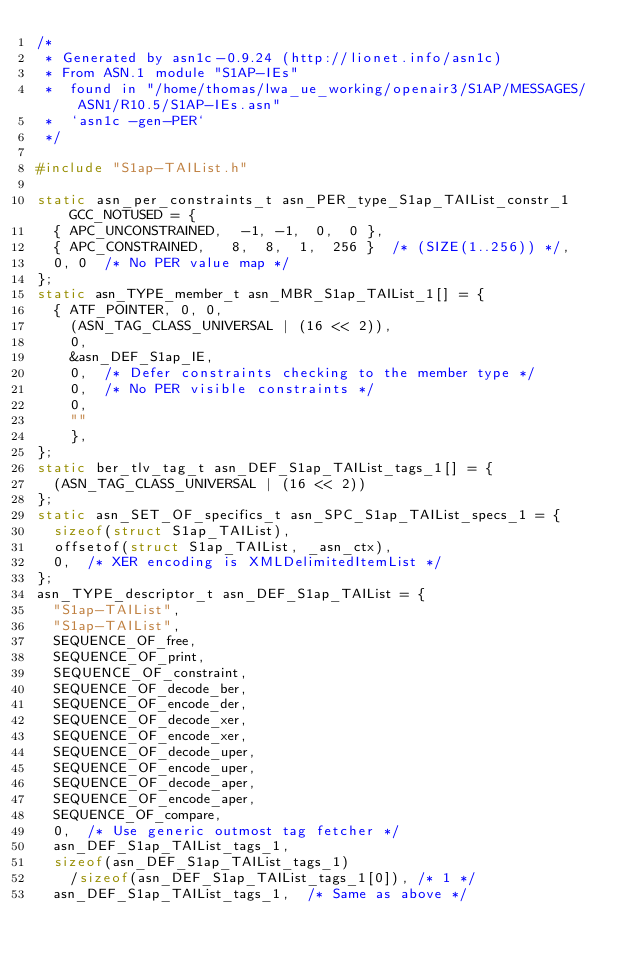Convert code to text. <code><loc_0><loc_0><loc_500><loc_500><_C_>/*
 * Generated by asn1c-0.9.24 (http://lionet.info/asn1c)
 * From ASN.1 module "S1AP-IEs"
 * 	found in "/home/thomas/lwa_ue_working/openair3/S1AP/MESSAGES/ASN1/R10.5/S1AP-IEs.asn"
 * 	`asn1c -gen-PER`
 */

#include "S1ap-TAIList.h"

static asn_per_constraints_t asn_PER_type_S1ap_TAIList_constr_1 GCC_NOTUSED = {
	{ APC_UNCONSTRAINED,	-1, -1,  0,  0 },
	{ APC_CONSTRAINED,	 8,  8,  1,  256 }	/* (SIZE(1..256)) */,
	0, 0	/* No PER value map */
};
static asn_TYPE_member_t asn_MBR_S1ap_TAIList_1[] = {
	{ ATF_POINTER, 0, 0,
		(ASN_TAG_CLASS_UNIVERSAL | (16 << 2)),
		0,
		&asn_DEF_S1ap_IE,
		0,	/* Defer constraints checking to the member type */
		0,	/* No PER visible constraints */
		0,
		""
		},
};
static ber_tlv_tag_t asn_DEF_S1ap_TAIList_tags_1[] = {
	(ASN_TAG_CLASS_UNIVERSAL | (16 << 2))
};
static asn_SET_OF_specifics_t asn_SPC_S1ap_TAIList_specs_1 = {
	sizeof(struct S1ap_TAIList),
	offsetof(struct S1ap_TAIList, _asn_ctx),
	0,	/* XER encoding is XMLDelimitedItemList */
};
asn_TYPE_descriptor_t asn_DEF_S1ap_TAIList = {
	"S1ap-TAIList",
	"S1ap-TAIList",
	SEQUENCE_OF_free,
	SEQUENCE_OF_print,
	SEQUENCE_OF_constraint,
	SEQUENCE_OF_decode_ber,
	SEQUENCE_OF_encode_der,
	SEQUENCE_OF_decode_xer,
	SEQUENCE_OF_encode_xer,
	SEQUENCE_OF_decode_uper,
	SEQUENCE_OF_encode_uper,
	SEQUENCE_OF_decode_aper,
	SEQUENCE_OF_encode_aper,
	SEQUENCE_OF_compare,
	0,	/* Use generic outmost tag fetcher */
	asn_DEF_S1ap_TAIList_tags_1,
	sizeof(asn_DEF_S1ap_TAIList_tags_1)
		/sizeof(asn_DEF_S1ap_TAIList_tags_1[0]), /* 1 */
	asn_DEF_S1ap_TAIList_tags_1,	/* Same as above */</code> 